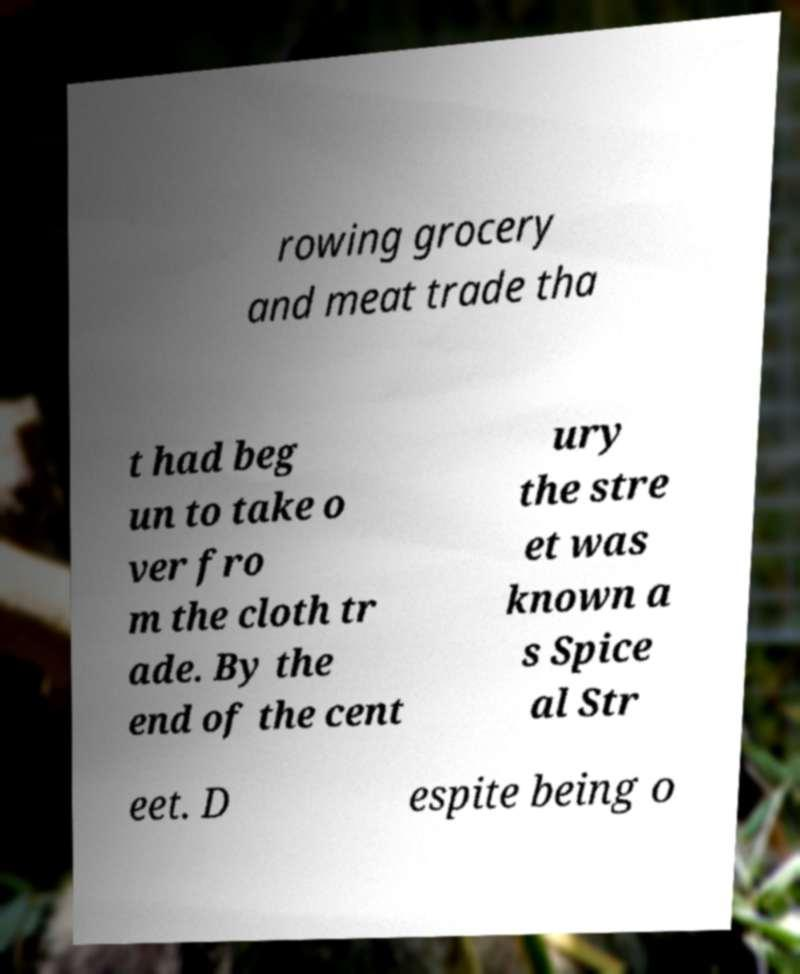For documentation purposes, I need the text within this image transcribed. Could you provide that? rowing grocery and meat trade tha t had beg un to take o ver fro m the cloth tr ade. By the end of the cent ury the stre et was known a s Spice al Str eet. D espite being o 